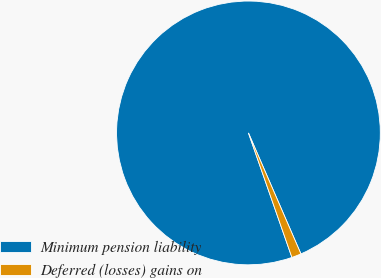Convert chart. <chart><loc_0><loc_0><loc_500><loc_500><pie_chart><fcel>Minimum pension liability<fcel>Deferred (losses) gains on<nl><fcel>98.83%<fcel>1.17%<nl></chart> 